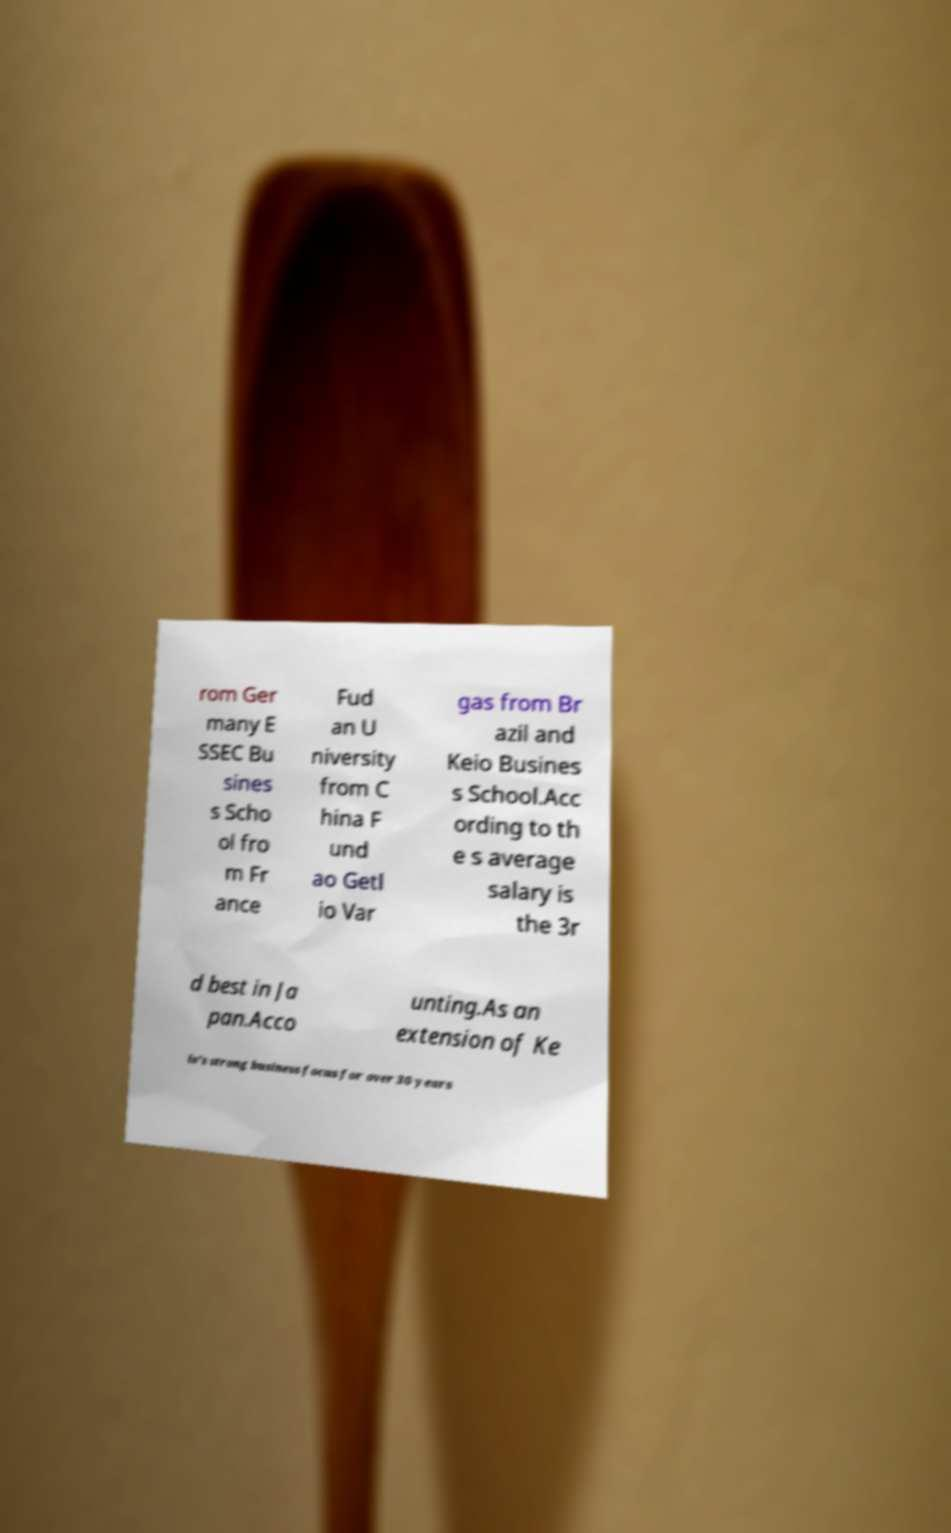I need the written content from this picture converted into text. Can you do that? rom Ger many E SSEC Bu sines s Scho ol fro m Fr ance Fud an U niversity from C hina F und ao Getl io Var gas from Br azil and Keio Busines s School.Acc ording to th e s average salary is the 3r d best in Ja pan.Acco unting.As an extension of Ke io's strong business focus for over 30 years 